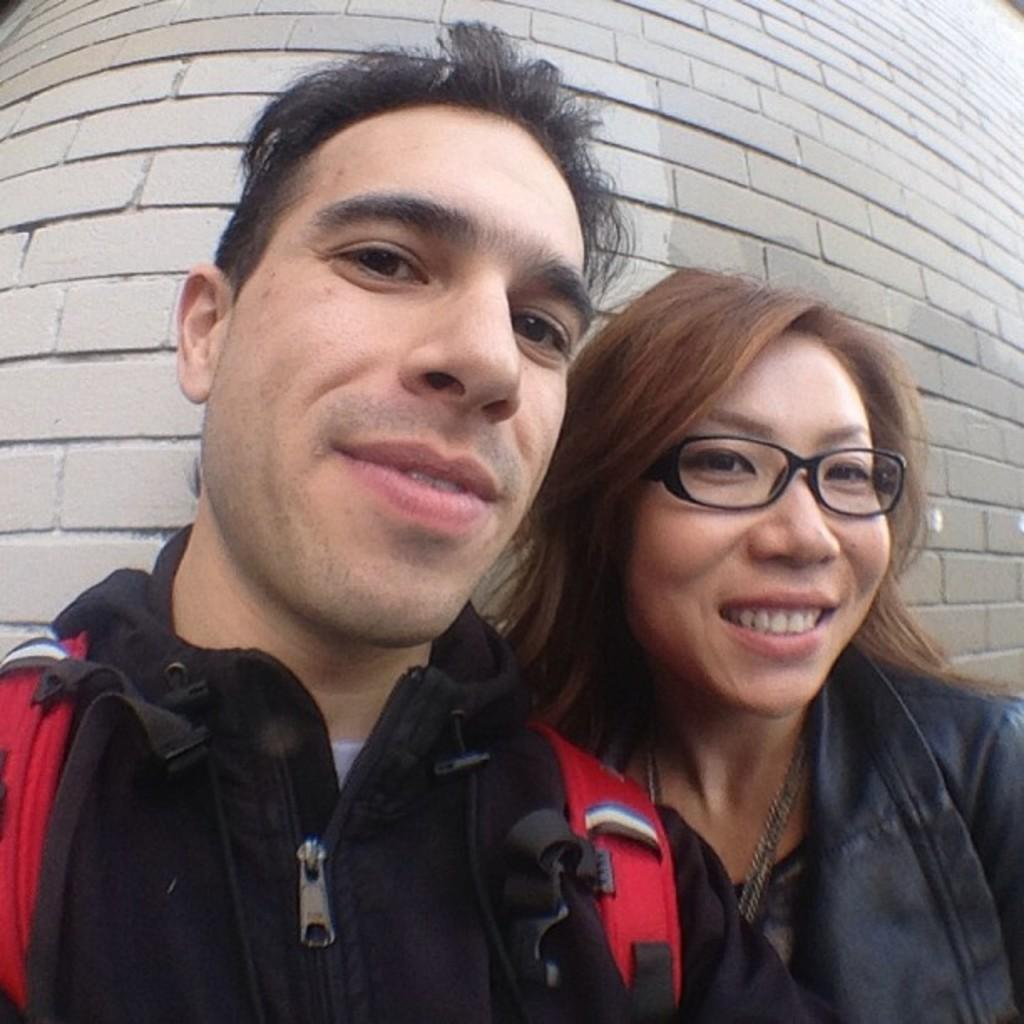Who are the people in the foreground of the image? There is a man and a woman in the foreground of the image. What can be seen in the background of the image? There is a wall in the background of the image. What type of rice is being cooked in the image? There is no rice present in the image. How is the hose being used in the image? There is no hose present in the image. 